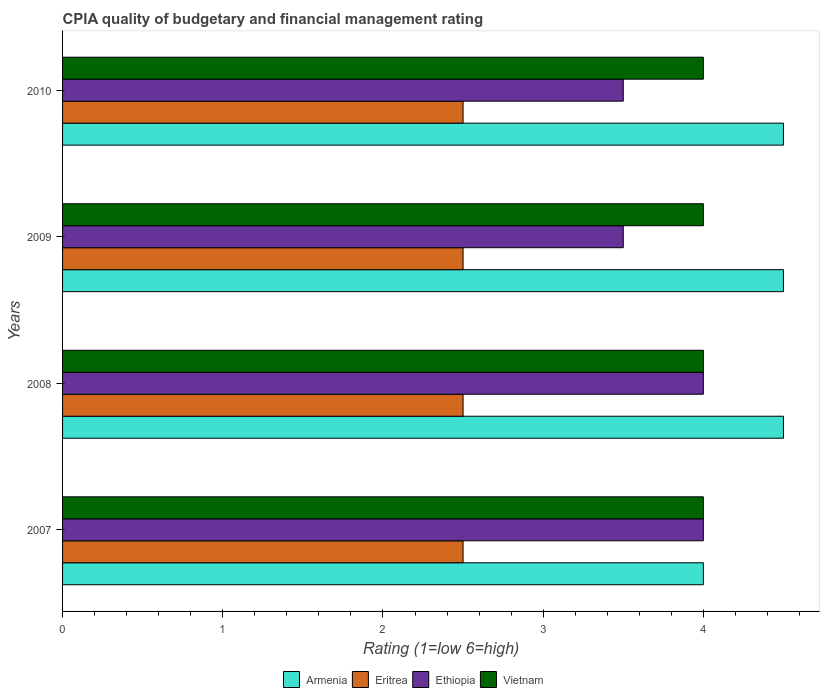Are the number of bars per tick equal to the number of legend labels?
Your response must be concise. Yes. What is the label of the 2nd group of bars from the top?
Your answer should be very brief. 2009. What is the CPIA rating in Eritrea in 2007?
Keep it short and to the point. 2.5. Across all years, what is the minimum CPIA rating in Armenia?
Your answer should be very brief. 4. In which year was the CPIA rating in Armenia maximum?
Give a very brief answer. 2008. What is the total CPIA rating in Ethiopia in the graph?
Ensure brevity in your answer.  15. What is the difference between the CPIA rating in Armenia in 2010 and the CPIA rating in Eritrea in 2007?
Ensure brevity in your answer.  2. In the year 2007, what is the difference between the CPIA rating in Vietnam and CPIA rating in Armenia?
Your answer should be very brief. 0. What is the ratio of the CPIA rating in Ethiopia in 2009 to that in 2010?
Keep it short and to the point. 1. Is the CPIA rating in Eritrea in 2008 less than that in 2010?
Your response must be concise. No. Is the difference between the CPIA rating in Vietnam in 2008 and 2009 greater than the difference between the CPIA rating in Armenia in 2008 and 2009?
Your answer should be very brief. No. What is the difference between the highest and the second highest CPIA rating in Vietnam?
Keep it short and to the point. 0. In how many years, is the CPIA rating in Vietnam greater than the average CPIA rating in Vietnam taken over all years?
Keep it short and to the point. 0. What does the 4th bar from the top in 2007 represents?
Make the answer very short. Armenia. What does the 3rd bar from the bottom in 2009 represents?
Make the answer very short. Ethiopia. Is it the case that in every year, the sum of the CPIA rating in Eritrea and CPIA rating in Ethiopia is greater than the CPIA rating in Armenia?
Keep it short and to the point. Yes. How many years are there in the graph?
Offer a terse response. 4. Does the graph contain any zero values?
Keep it short and to the point. No. How many legend labels are there?
Your answer should be compact. 4. How are the legend labels stacked?
Your answer should be very brief. Horizontal. What is the title of the graph?
Keep it short and to the point. CPIA quality of budgetary and financial management rating. Does "Nigeria" appear as one of the legend labels in the graph?
Your answer should be very brief. No. What is the label or title of the X-axis?
Ensure brevity in your answer.  Rating (1=low 6=high). What is the label or title of the Y-axis?
Your response must be concise. Years. What is the Rating (1=low 6=high) of Armenia in 2007?
Offer a very short reply. 4. What is the Rating (1=low 6=high) of Eritrea in 2007?
Ensure brevity in your answer.  2.5. What is the Rating (1=low 6=high) of Ethiopia in 2007?
Ensure brevity in your answer.  4. What is the Rating (1=low 6=high) in Vietnam in 2007?
Give a very brief answer. 4. What is the Rating (1=low 6=high) in Armenia in 2008?
Your response must be concise. 4.5. What is the Rating (1=low 6=high) of Ethiopia in 2008?
Your answer should be very brief. 4. What is the Rating (1=low 6=high) of Armenia in 2009?
Keep it short and to the point. 4.5. What is the Rating (1=low 6=high) in Eritrea in 2009?
Your answer should be compact. 2.5. What is the Rating (1=low 6=high) of Ethiopia in 2009?
Your response must be concise. 3.5. What is the Rating (1=low 6=high) of Armenia in 2010?
Your response must be concise. 4.5. Across all years, what is the maximum Rating (1=low 6=high) of Armenia?
Offer a terse response. 4.5. Across all years, what is the maximum Rating (1=low 6=high) in Ethiopia?
Make the answer very short. 4. Across all years, what is the maximum Rating (1=low 6=high) in Vietnam?
Ensure brevity in your answer.  4. What is the total Rating (1=low 6=high) of Ethiopia in the graph?
Provide a succinct answer. 15. What is the total Rating (1=low 6=high) in Vietnam in the graph?
Offer a terse response. 16. What is the difference between the Rating (1=low 6=high) in Armenia in 2007 and that in 2008?
Provide a succinct answer. -0.5. What is the difference between the Rating (1=low 6=high) in Armenia in 2007 and that in 2010?
Your answer should be compact. -0.5. What is the difference between the Rating (1=low 6=high) in Ethiopia in 2007 and that in 2010?
Ensure brevity in your answer.  0.5. What is the difference between the Rating (1=low 6=high) of Armenia in 2008 and that in 2009?
Keep it short and to the point. 0. What is the difference between the Rating (1=low 6=high) of Eritrea in 2008 and that in 2009?
Offer a very short reply. 0. What is the difference between the Rating (1=low 6=high) in Ethiopia in 2008 and that in 2010?
Offer a terse response. 0.5. What is the difference between the Rating (1=low 6=high) in Eritrea in 2009 and that in 2010?
Your answer should be very brief. 0. What is the difference between the Rating (1=low 6=high) in Vietnam in 2009 and that in 2010?
Provide a succinct answer. 0. What is the difference between the Rating (1=low 6=high) of Armenia in 2007 and the Rating (1=low 6=high) of Vietnam in 2008?
Your answer should be very brief. 0. What is the difference between the Rating (1=low 6=high) in Eritrea in 2007 and the Rating (1=low 6=high) in Ethiopia in 2008?
Your answer should be compact. -1.5. What is the difference between the Rating (1=low 6=high) of Eritrea in 2007 and the Rating (1=low 6=high) of Vietnam in 2008?
Offer a very short reply. -1.5. What is the difference between the Rating (1=low 6=high) in Armenia in 2007 and the Rating (1=low 6=high) in Ethiopia in 2009?
Make the answer very short. 0.5. What is the difference between the Rating (1=low 6=high) in Armenia in 2007 and the Rating (1=low 6=high) in Vietnam in 2009?
Offer a very short reply. 0. What is the difference between the Rating (1=low 6=high) in Ethiopia in 2007 and the Rating (1=low 6=high) in Vietnam in 2009?
Provide a succinct answer. 0. What is the difference between the Rating (1=low 6=high) of Armenia in 2007 and the Rating (1=low 6=high) of Eritrea in 2010?
Your answer should be compact. 1.5. What is the difference between the Rating (1=low 6=high) in Armenia in 2007 and the Rating (1=low 6=high) in Ethiopia in 2010?
Provide a short and direct response. 0.5. What is the difference between the Rating (1=low 6=high) in Eritrea in 2007 and the Rating (1=low 6=high) in Ethiopia in 2010?
Give a very brief answer. -1. What is the difference between the Rating (1=low 6=high) in Armenia in 2008 and the Rating (1=low 6=high) in Eritrea in 2009?
Offer a terse response. 2. What is the difference between the Rating (1=low 6=high) in Eritrea in 2008 and the Rating (1=low 6=high) in Ethiopia in 2009?
Your answer should be compact. -1. What is the difference between the Rating (1=low 6=high) in Eritrea in 2008 and the Rating (1=low 6=high) in Vietnam in 2009?
Your answer should be very brief. -1.5. What is the difference between the Rating (1=low 6=high) in Armenia in 2008 and the Rating (1=low 6=high) in Eritrea in 2010?
Give a very brief answer. 2. What is the difference between the Rating (1=low 6=high) of Armenia in 2009 and the Rating (1=low 6=high) of Eritrea in 2010?
Offer a very short reply. 2. What is the difference between the Rating (1=low 6=high) in Armenia in 2009 and the Rating (1=low 6=high) in Vietnam in 2010?
Keep it short and to the point. 0.5. What is the difference between the Rating (1=low 6=high) of Eritrea in 2009 and the Rating (1=low 6=high) of Vietnam in 2010?
Make the answer very short. -1.5. What is the difference between the Rating (1=low 6=high) of Ethiopia in 2009 and the Rating (1=low 6=high) of Vietnam in 2010?
Provide a succinct answer. -0.5. What is the average Rating (1=low 6=high) of Armenia per year?
Provide a short and direct response. 4.38. What is the average Rating (1=low 6=high) in Ethiopia per year?
Your response must be concise. 3.75. In the year 2007, what is the difference between the Rating (1=low 6=high) of Eritrea and Rating (1=low 6=high) of Ethiopia?
Your answer should be very brief. -1.5. In the year 2007, what is the difference between the Rating (1=low 6=high) in Eritrea and Rating (1=low 6=high) in Vietnam?
Provide a succinct answer. -1.5. In the year 2008, what is the difference between the Rating (1=low 6=high) of Eritrea and Rating (1=low 6=high) of Vietnam?
Offer a terse response. -1.5. In the year 2008, what is the difference between the Rating (1=low 6=high) in Ethiopia and Rating (1=low 6=high) in Vietnam?
Keep it short and to the point. 0. In the year 2009, what is the difference between the Rating (1=low 6=high) in Armenia and Rating (1=low 6=high) in Ethiopia?
Provide a short and direct response. 1. In the year 2009, what is the difference between the Rating (1=low 6=high) in Eritrea and Rating (1=low 6=high) in Ethiopia?
Your answer should be compact. -1. In the year 2009, what is the difference between the Rating (1=low 6=high) of Eritrea and Rating (1=low 6=high) of Vietnam?
Your answer should be compact. -1.5. In the year 2009, what is the difference between the Rating (1=low 6=high) of Ethiopia and Rating (1=low 6=high) of Vietnam?
Keep it short and to the point. -0.5. In the year 2010, what is the difference between the Rating (1=low 6=high) in Eritrea and Rating (1=low 6=high) in Ethiopia?
Your answer should be compact. -1. In the year 2010, what is the difference between the Rating (1=low 6=high) of Eritrea and Rating (1=low 6=high) of Vietnam?
Your response must be concise. -1.5. What is the ratio of the Rating (1=low 6=high) of Armenia in 2007 to that in 2008?
Provide a succinct answer. 0.89. What is the ratio of the Rating (1=low 6=high) of Ethiopia in 2007 to that in 2008?
Give a very brief answer. 1. What is the ratio of the Rating (1=low 6=high) in Vietnam in 2007 to that in 2008?
Offer a very short reply. 1. What is the ratio of the Rating (1=low 6=high) in Armenia in 2007 to that in 2009?
Your answer should be compact. 0.89. What is the ratio of the Rating (1=low 6=high) in Vietnam in 2007 to that in 2009?
Your answer should be compact. 1. What is the ratio of the Rating (1=low 6=high) of Ethiopia in 2007 to that in 2010?
Your answer should be compact. 1.14. What is the ratio of the Rating (1=low 6=high) in Armenia in 2008 to that in 2009?
Provide a succinct answer. 1. What is the ratio of the Rating (1=low 6=high) of Eritrea in 2008 to that in 2009?
Give a very brief answer. 1. What is the ratio of the Rating (1=low 6=high) of Vietnam in 2008 to that in 2009?
Give a very brief answer. 1. What is the ratio of the Rating (1=low 6=high) in Armenia in 2008 to that in 2010?
Your response must be concise. 1. What is the ratio of the Rating (1=low 6=high) of Eritrea in 2008 to that in 2010?
Make the answer very short. 1. What is the ratio of the Rating (1=low 6=high) in Eritrea in 2009 to that in 2010?
Your response must be concise. 1. What is the ratio of the Rating (1=low 6=high) of Ethiopia in 2009 to that in 2010?
Ensure brevity in your answer.  1. What is the difference between the highest and the second highest Rating (1=low 6=high) in Ethiopia?
Offer a terse response. 0. What is the difference between the highest and the lowest Rating (1=low 6=high) of Armenia?
Offer a terse response. 0.5. What is the difference between the highest and the lowest Rating (1=low 6=high) in Eritrea?
Provide a succinct answer. 0. What is the difference between the highest and the lowest Rating (1=low 6=high) in Vietnam?
Your answer should be compact. 0. 